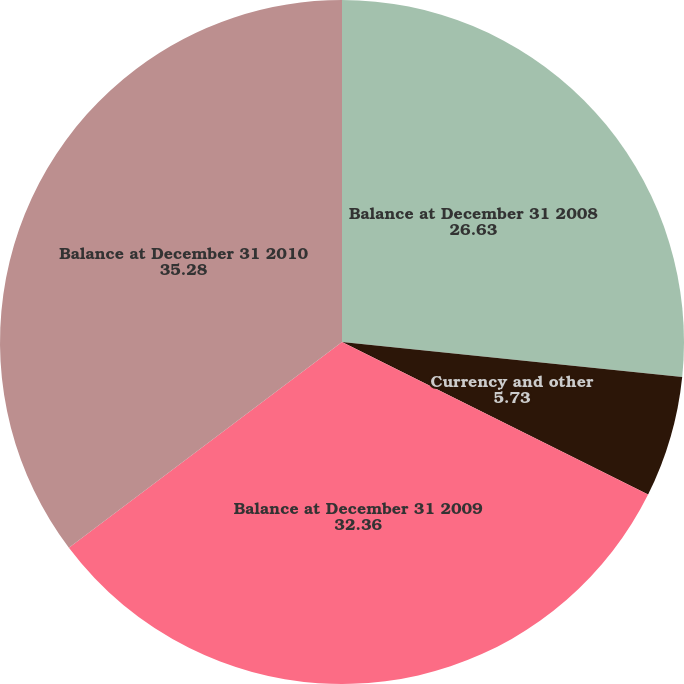<chart> <loc_0><loc_0><loc_500><loc_500><pie_chart><fcel>Balance at December 31 2008<fcel>Currency and other<fcel>Balance at December 31 2009<fcel>Balance at December 31 2010<nl><fcel>26.63%<fcel>5.73%<fcel>32.36%<fcel>35.28%<nl></chart> 